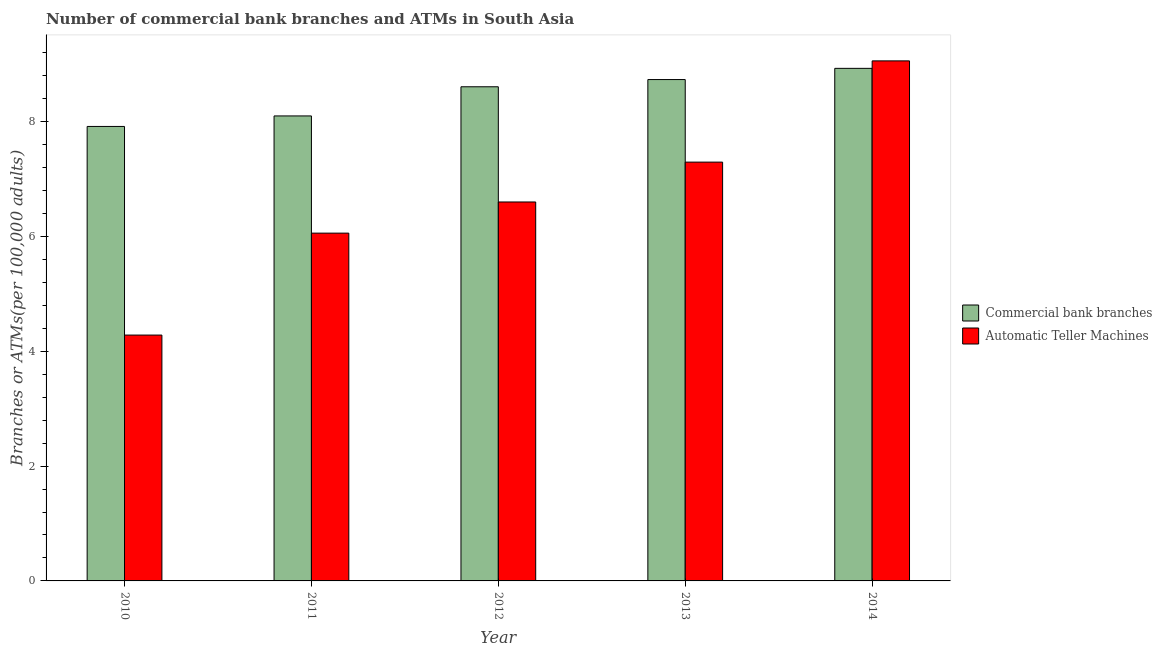How many groups of bars are there?
Give a very brief answer. 5. Are the number of bars on each tick of the X-axis equal?
Offer a terse response. Yes. How many bars are there on the 2nd tick from the left?
Provide a short and direct response. 2. In how many cases, is the number of bars for a given year not equal to the number of legend labels?
Keep it short and to the point. 0. What is the number of commercal bank branches in 2010?
Provide a short and direct response. 7.91. Across all years, what is the maximum number of commercal bank branches?
Offer a terse response. 8.93. Across all years, what is the minimum number of commercal bank branches?
Your response must be concise. 7.91. In which year was the number of atms maximum?
Give a very brief answer. 2014. What is the total number of commercal bank branches in the graph?
Keep it short and to the point. 42.27. What is the difference between the number of commercal bank branches in 2011 and that in 2013?
Make the answer very short. -0.63. What is the difference between the number of commercal bank branches in 2012 and the number of atms in 2014?
Your answer should be very brief. -0.32. What is the average number of atms per year?
Your response must be concise. 6.66. What is the ratio of the number of atms in 2010 to that in 2013?
Offer a very short reply. 0.59. Is the number of atms in 2011 less than that in 2013?
Your response must be concise. Yes. Is the difference between the number of atms in 2010 and 2014 greater than the difference between the number of commercal bank branches in 2010 and 2014?
Your response must be concise. No. What is the difference between the highest and the second highest number of atms?
Your response must be concise. 1.76. What is the difference between the highest and the lowest number of commercal bank branches?
Your answer should be very brief. 1.01. In how many years, is the number of atms greater than the average number of atms taken over all years?
Keep it short and to the point. 2. What does the 2nd bar from the left in 2014 represents?
Provide a succinct answer. Automatic Teller Machines. What does the 1st bar from the right in 2011 represents?
Offer a terse response. Automatic Teller Machines. How many bars are there?
Give a very brief answer. 10. Are all the bars in the graph horizontal?
Keep it short and to the point. No. What is the difference between two consecutive major ticks on the Y-axis?
Your answer should be compact. 2. Does the graph contain any zero values?
Give a very brief answer. No. Does the graph contain grids?
Make the answer very short. No. What is the title of the graph?
Your answer should be very brief. Number of commercial bank branches and ATMs in South Asia. Does "Long-term debt" appear as one of the legend labels in the graph?
Offer a terse response. No. What is the label or title of the X-axis?
Ensure brevity in your answer.  Year. What is the label or title of the Y-axis?
Give a very brief answer. Branches or ATMs(per 100,0 adults). What is the Branches or ATMs(per 100,000 adults) of Commercial bank branches in 2010?
Provide a short and direct response. 7.91. What is the Branches or ATMs(per 100,000 adults) in Automatic Teller Machines in 2010?
Provide a succinct answer. 4.28. What is the Branches or ATMs(per 100,000 adults) in Commercial bank branches in 2011?
Your response must be concise. 8.1. What is the Branches or ATMs(per 100,000 adults) of Automatic Teller Machines in 2011?
Ensure brevity in your answer.  6.06. What is the Branches or ATMs(per 100,000 adults) in Commercial bank branches in 2012?
Offer a very short reply. 8.61. What is the Branches or ATMs(per 100,000 adults) of Automatic Teller Machines in 2012?
Make the answer very short. 6.6. What is the Branches or ATMs(per 100,000 adults) of Commercial bank branches in 2013?
Your answer should be compact. 8.73. What is the Branches or ATMs(per 100,000 adults) in Automatic Teller Machines in 2013?
Make the answer very short. 7.29. What is the Branches or ATMs(per 100,000 adults) of Commercial bank branches in 2014?
Provide a short and direct response. 8.93. What is the Branches or ATMs(per 100,000 adults) in Automatic Teller Machines in 2014?
Offer a very short reply. 9.06. Across all years, what is the maximum Branches or ATMs(per 100,000 adults) of Commercial bank branches?
Give a very brief answer. 8.93. Across all years, what is the maximum Branches or ATMs(per 100,000 adults) of Automatic Teller Machines?
Your answer should be very brief. 9.06. Across all years, what is the minimum Branches or ATMs(per 100,000 adults) in Commercial bank branches?
Keep it short and to the point. 7.91. Across all years, what is the minimum Branches or ATMs(per 100,000 adults) of Automatic Teller Machines?
Offer a very short reply. 4.28. What is the total Branches or ATMs(per 100,000 adults) of Commercial bank branches in the graph?
Keep it short and to the point. 42.27. What is the total Branches or ATMs(per 100,000 adults) of Automatic Teller Machines in the graph?
Offer a terse response. 33.29. What is the difference between the Branches or ATMs(per 100,000 adults) in Commercial bank branches in 2010 and that in 2011?
Provide a short and direct response. -0.18. What is the difference between the Branches or ATMs(per 100,000 adults) of Automatic Teller Machines in 2010 and that in 2011?
Offer a very short reply. -1.78. What is the difference between the Branches or ATMs(per 100,000 adults) of Commercial bank branches in 2010 and that in 2012?
Your answer should be very brief. -0.69. What is the difference between the Branches or ATMs(per 100,000 adults) in Automatic Teller Machines in 2010 and that in 2012?
Provide a short and direct response. -2.32. What is the difference between the Branches or ATMs(per 100,000 adults) in Commercial bank branches in 2010 and that in 2013?
Provide a short and direct response. -0.82. What is the difference between the Branches or ATMs(per 100,000 adults) of Automatic Teller Machines in 2010 and that in 2013?
Give a very brief answer. -3.01. What is the difference between the Branches or ATMs(per 100,000 adults) of Commercial bank branches in 2010 and that in 2014?
Provide a succinct answer. -1.01. What is the difference between the Branches or ATMs(per 100,000 adults) in Automatic Teller Machines in 2010 and that in 2014?
Give a very brief answer. -4.77. What is the difference between the Branches or ATMs(per 100,000 adults) of Commercial bank branches in 2011 and that in 2012?
Ensure brevity in your answer.  -0.51. What is the difference between the Branches or ATMs(per 100,000 adults) of Automatic Teller Machines in 2011 and that in 2012?
Ensure brevity in your answer.  -0.54. What is the difference between the Branches or ATMs(per 100,000 adults) in Commercial bank branches in 2011 and that in 2013?
Give a very brief answer. -0.63. What is the difference between the Branches or ATMs(per 100,000 adults) of Automatic Teller Machines in 2011 and that in 2013?
Ensure brevity in your answer.  -1.24. What is the difference between the Branches or ATMs(per 100,000 adults) of Commercial bank branches in 2011 and that in 2014?
Give a very brief answer. -0.83. What is the difference between the Branches or ATMs(per 100,000 adults) in Automatic Teller Machines in 2011 and that in 2014?
Offer a terse response. -3. What is the difference between the Branches or ATMs(per 100,000 adults) in Commercial bank branches in 2012 and that in 2013?
Give a very brief answer. -0.13. What is the difference between the Branches or ATMs(per 100,000 adults) in Automatic Teller Machines in 2012 and that in 2013?
Provide a succinct answer. -0.69. What is the difference between the Branches or ATMs(per 100,000 adults) of Commercial bank branches in 2012 and that in 2014?
Ensure brevity in your answer.  -0.32. What is the difference between the Branches or ATMs(per 100,000 adults) in Automatic Teller Machines in 2012 and that in 2014?
Keep it short and to the point. -2.46. What is the difference between the Branches or ATMs(per 100,000 adults) of Commercial bank branches in 2013 and that in 2014?
Offer a terse response. -0.2. What is the difference between the Branches or ATMs(per 100,000 adults) of Automatic Teller Machines in 2013 and that in 2014?
Provide a short and direct response. -1.76. What is the difference between the Branches or ATMs(per 100,000 adults) in Commercial bank branches in 2010 and the Branches or ATMs(per 100,000 adults) in Automatic Teller Machines in 2011?
Offer a terse response. 1.86. What is the difference between the Branches or ATMs(per 100,000 adults) of Commercial bank branches in 2010 and the Branches or ATMs(per 100,000 adults) of Automatic Teller Machines in 2012?
Ensure brevity in your answer.  1.32. What is the difference between the Branches or ATMs(per 100,000 adults) of Commercial bank branches in 2010 and the Branches or ATMs(per 100,000 adults) of Automatic Teller Machines in 2013?
Ensure brevity in your answer.  0.62. What is the difference between the Branches or ATMs(per 100,000 adults) in Commercial bank branches in 2010 and the Branches or ATMs(per 100,000 adults) in Automatic Teller Machines in 2014?
Make the answer very short. -1.14. What is the difference between the Branches or ATMs(per 100,000 adults) of Commercial bank branches in 2011 and the Branches or ATMs(per 100,000 adults) of Automatic Teller Machines in 2012?
Your answer should be very brief. 1.5. What is the difference between the Branches or ATMs(per 100,000 adults) in Commercial bank branches in 2011 and the Branches or ATMs(per 100,000 adults) in Automatic Teller Machines in 2013?
Provide a succinct answer. 0.8. What is the difference between the Branches or ATMs(per 100,000 adults) of Commercial bank branches in 2011 and the Branches or ATMs(per 100,000 adults) of Automatic Teller Machines in 2014?
Your answer should be compact. -0.96. What is the difference between the Branches or ATMs(per 100,000 adults) of Commercial bank branches in 2012 and the Branches or ATMs(per 100,000 adults) of Automatic Teller Machines in 2013?
Provide a succinct answer. 1.31. What is the difference between the Branches or ATMs(per 100,000 adults) in Commercial bank branches in 2012 and the Branches or ATMs(per 100,000 adults) in Automatic Teller Machines in 2014?
Offer a very short reply. -0.45. What is the difference between the Branches or ATMs(per 100,000 adults) in Commercial bank branches in 2013 and the Branches or ATMs(per 100,000 adults) in Automatic Teller Machines in 2014?
Give a very brief answer. -0.33. What is the average Branches or ATMs(per 100,000 adults) of Commercial bank branches per year?
Your answer should be compact. 8.45. What is the average Branches or ATMs(per 100,000 adults) of Automatic Teller Machines per year?
Make the answer very short. 6.66. In the year 2010, what is the difference between the Branches or ATMs(per 100,000 adults) in Commercial bank branches and Branches or ATMs(per 100,000 adults) in Automatic Teller Machines?
Provide a succinct answer. 3.63. In the year 2011, what is the difference between the Branches or ATMs(per 100,000 adults) of Commercial bank branches and Branches or ATMs(per 100,000 adults) of Automatic Teller Machines?
Keep it short and to the point. 2.04. In the year 2012, what is the difference between the Branches or ATMs(per 100,000 adults) of Commercial bank branches and Branches or ATMs(per 100,000 adults) of Automatic Teller Machines?
Ensure brevity in your answer.  2.01. In the year 2013, what is the difference between the Branches or ATMs(per 100,000 adults) in Commercial bank branches and Branches or ATMs(per 100,000 adults) in Automatic Teller Machines?
Your response must be concise. 1.44. In the year 2014, what is the difference between the Branches or ATMs(per 100,000 adults) of Commercial bank branches and Branches or ATMs(per 100,000 adults) of Automatic Teller Machines?
Your answer should be very brief. -0.13. What is the ratio of the Branches or ATMs(per 100,000 adults) in Commercial bank branches in 2010 to that in 2011?
Give a very brief answer. 0.98. What is the ratio of the Branches or ATMs(per 100,000 adults) of Automatic Teller Machines in 2010 to that in 2011?
Provide a succinct answer. 0.71. What is the ratio of the Branches or ATMs(per 100,000 adults) in Commercial bank branches in 2010 to that in 2012?
Ensure brevity in your answer.  0.92. What is the ratio of the Branches or ATMs(per 100,000 adults) in Automatic Teller Machines in 2010 to that in 2012?
Provide a succinct answer. 0.65. What is the ratio of the Branches or ATMs(per 100,000 adults) in Commercial bank branches in 2010 to that in 2013?
Provide a short and direct response. 0.91. What is the ratio of the Branches or ATMs(per 100,000 adults) in Automatic Teller Machines in 2010 to that in 2013?
Offer a very short reply. 0.59. What is the ratio of the Branches or ATMs(per 100,000 adults) of Commercial bank branches in 2010 to that in 2014?
Your answer should be compact. 0.89. What is the ratio of the Branches or ATMs(per 100,000 adults) of Automatic Teller Machines in 2010 to that in 2014?
Your response must be concise. 0.47. What is the ratio of the Branches or ATMs(per 100,000 adults) in Commercial bank branches in 2011 to that in 2012?
Provide a succinct answer. 0.94. What is the ratio of the Branches or ATMs(per 100,000 adults) in Automatic Teller Machines in 2011 to that in 2012?
Provide a short and direct response. 0.92. What is the ratio of the Branches or ATMs(per 100,000 adults) of Commercial bank branches in 2011 to that in 2013?
Offer a terse response. 0.93. What is the ratio of the Branches or ATMs(per 100,000 adults) of Automatic Teller Machines in 2011 to that in 2013?
Keep it short and to the point. 0.83. What is the ratio of the Branches or ATMs(per 100,000 adults) of Commercial bank branches in 2011 to that in 2014?
Keep it short and to the point. 0.91. What is the ratio of the Branches or ATMs(per 100,000 adults) of Automatic Teller Machines in 2011 to that in 2014?
Provide a succinct answer. 0.67. What is the ratio of the Branches or ATMs(per 100,000 adults) in Commercial bank branches in 2012 to that in 2013?
Keep it short and to the point. 0.99. What is the ratio of the Branches or ATMs(per 100,000 adults) in Automatic Teller Machines in 2012 to that in 2013?
Your response must be concise. 0.9. What is the ratio of the Branches or ATMs(per 100,000 adults) in Commercial bank branches in 2012 to that in 2014?
Offer a terse response. 0.96. What is the ratio of the Branches or ATMs(per 100,000 adults) in Automatic Teller Machines in 2012 to that in 2014?
Ensure brevity in your answer.  0.73. What is the ratio of the Branches or ATMs(per 100,000 adults) in Commercial bank branches in 2013 to that in 2014?
Your answer should be very brief. 0.98. What is the ratio of the Branches or ATMs(per 100,000 adults) of Automatic Teller Machines in 2013 to that in 2014?
Your answer should be very brief. 0.81. What is the difference between the highest and the second highest Branches or ATMs(per 100,000 adults) of Commercial bank branches?
Keep it short and to the point. 0.2. What is the difference between the highest and the second highest Branches or ATMs(per 100,000 adults) in Automatic Teller Machines?
Your answer should be compact. 1.76. What is the difference between the highest and the lowest Branches or ATMs(per 100,000 adults) in Commercial bank branches?
Make the answer very short. 1.01. What is the difference between the highest and the lowest Branches or ATMs(per 100,000 adults) in Automatic Teller Machines?
Your response must be concise. 4.77. 